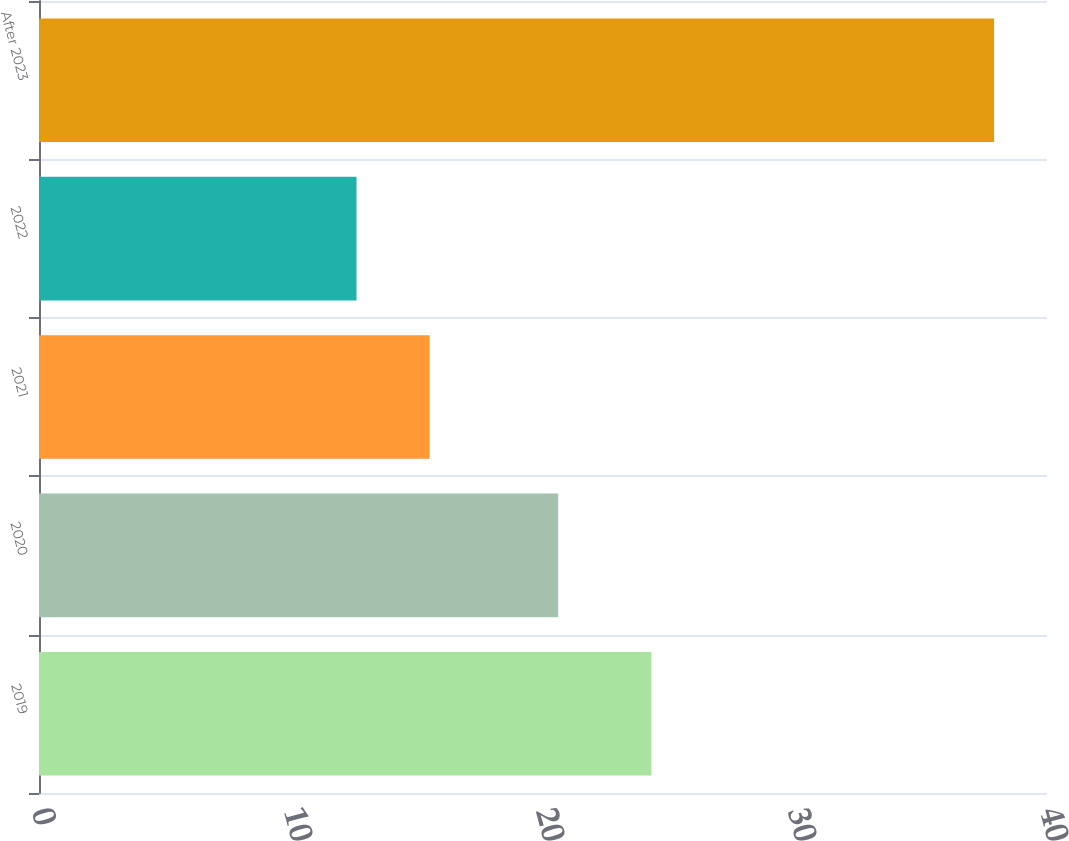<chart> <loc_0><loc_0><loc_500><loc_500><bar_chart><fcel>2019<fcel>2020<fcel>2021<fcel>2022<fcel>After 2023<nl><fcel>24.3<fcel>20.6<fcel>15.5<fcel>12.6<fcel>37.9<nl></chart> 